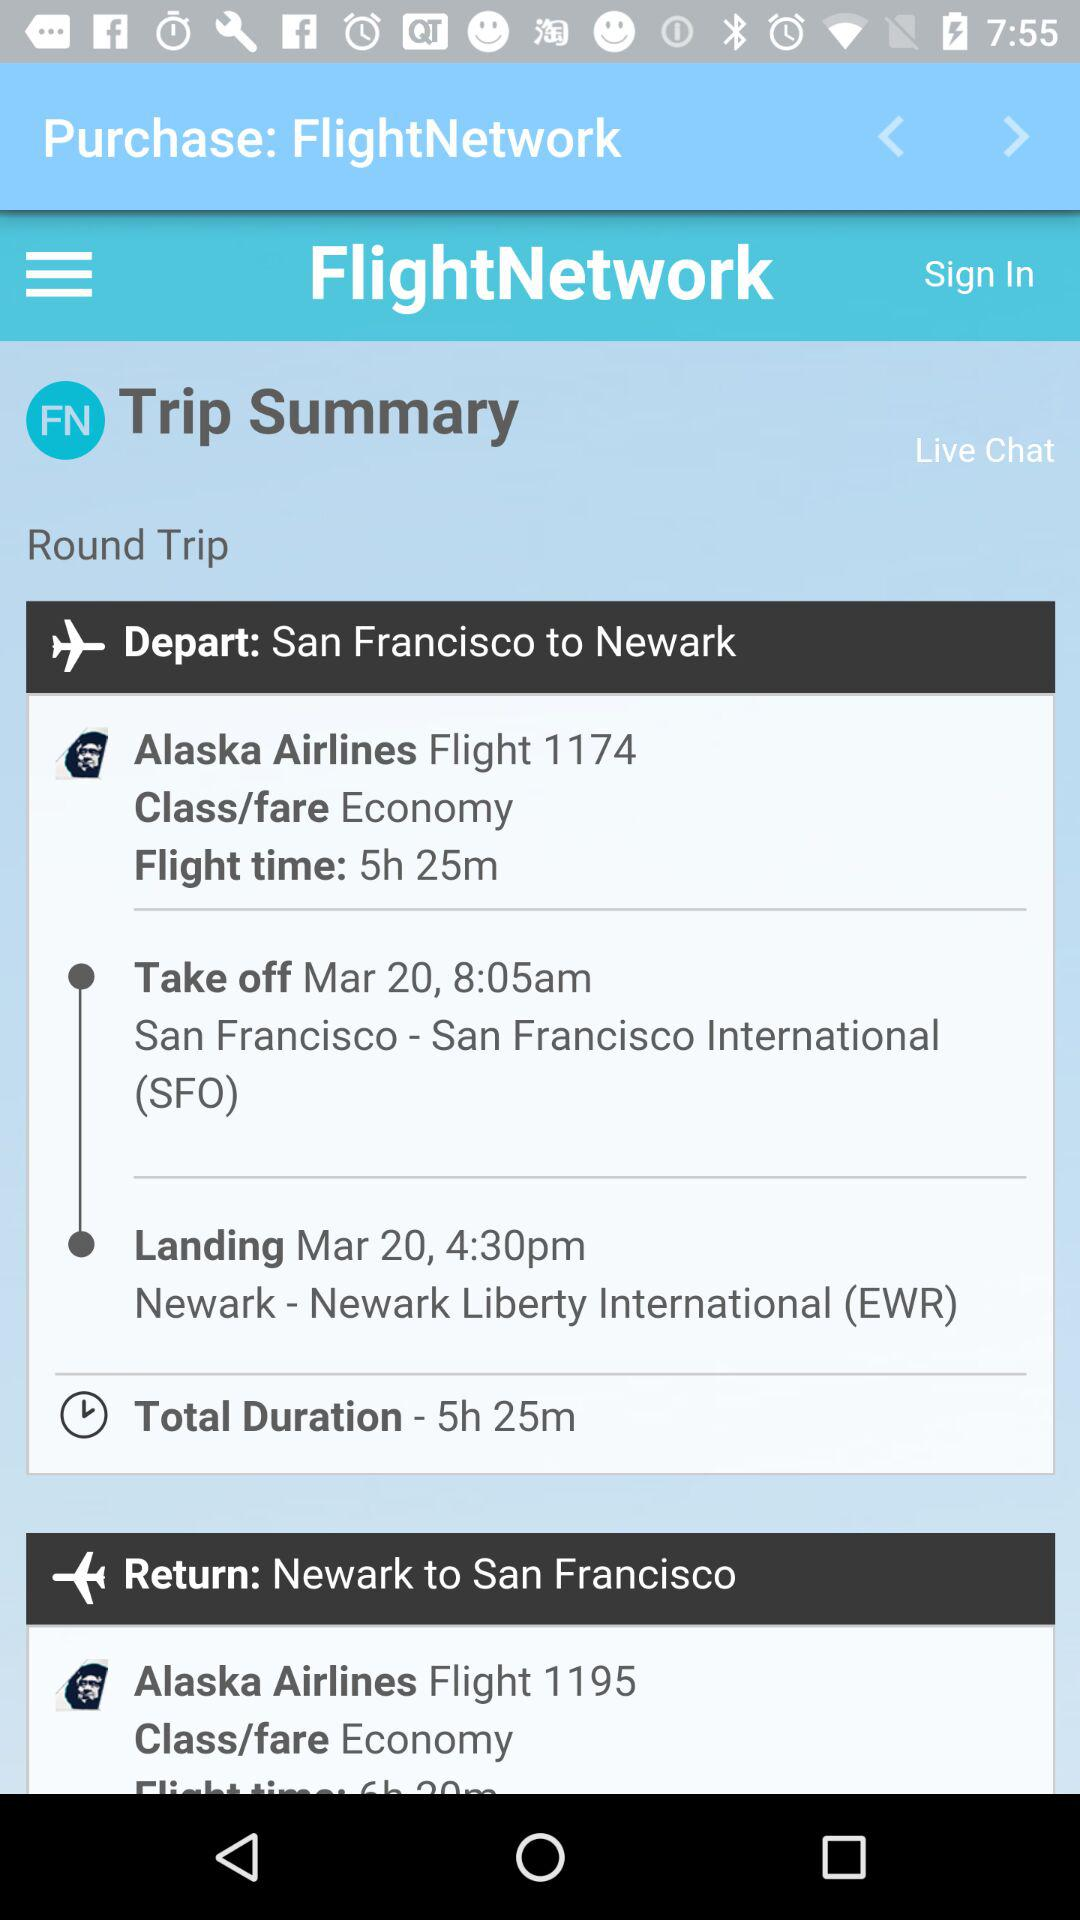What is the landing date? The landing date is March 20. 